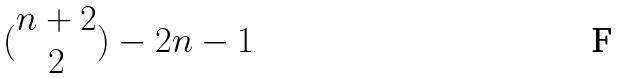Convert formula to latex. <formula><loc_0><loc_0><loc_500><loc_500>( \begin{matrix} n + 2 \\ 2 \end{matrix} ) - 2 n - 1</formula> 